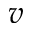<formula> <loc_0><loc_0><loc_500><loc_500>v</formula> 